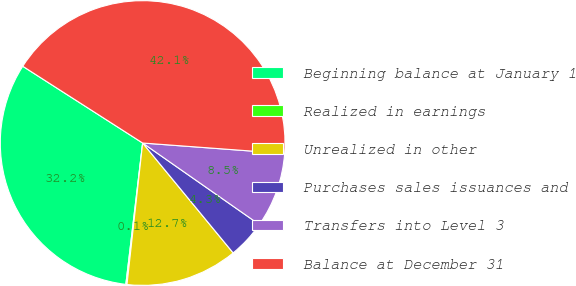Convert chart. <chart><loc_0><loc_0><loc_500><loc_500><pie_chart><fcel>Beginning balance at January 1<fcel>Realized in earnings<fcel>Unrealized in other<fcel>Purchases sales issuances and<fcel>Transfers into Level 3<fcel>Balance at December 31<nl><fcel>32.18%<fcel>0.13%<fcel>12.72%<fcel>4.33%<fcel>8.53%<fcel>42.11%<nl></chart> 